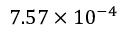Convert formula to latex. <formula><loc_0><loc_0><loc_500><loc_500>7 . 5 7 \times 1 0 ^ { - 4 }</formula> 